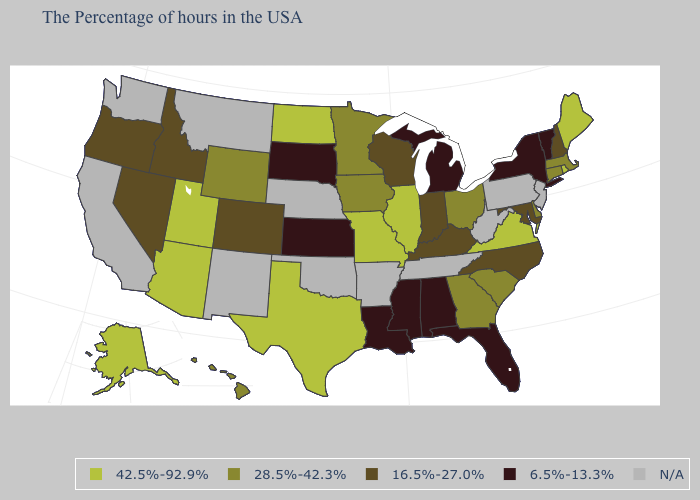How many symbols are there in the legend?
Keep it brief. 5. What is the value of Arkansas?
Short answer required. N/A. What is the value of Minnesota?
Quick response, please. 28.5%-42.3%. What is the value of California?
Give a very brief answer. N/A. What is the highest value in states that border New Hampshire?
Write a very short answer. 42.5%-92.9%. What is the lowest value in the Northeast?
Short answer required. 6.5%-13.3%. Which states have the lowest value in the West?
Short answer required. Colorado, Idaho, Nevada, Oregon. Is the legend a continuous bar?
Short answer required. No. Is the legend a continuous bar?
Give a very brief answer. No. What is the value of Idaho?
Short answer required. 16.5%-27.0%. Which states hav the highest value in the Northeast?
Quick response, please. Maine, Rhode Island. Among the states that border New Hampshire , which have the highest value?
Answer briefly. Maine. Does Vermont have the lowest value in the USA?
Give a very brief answer. Yes. 